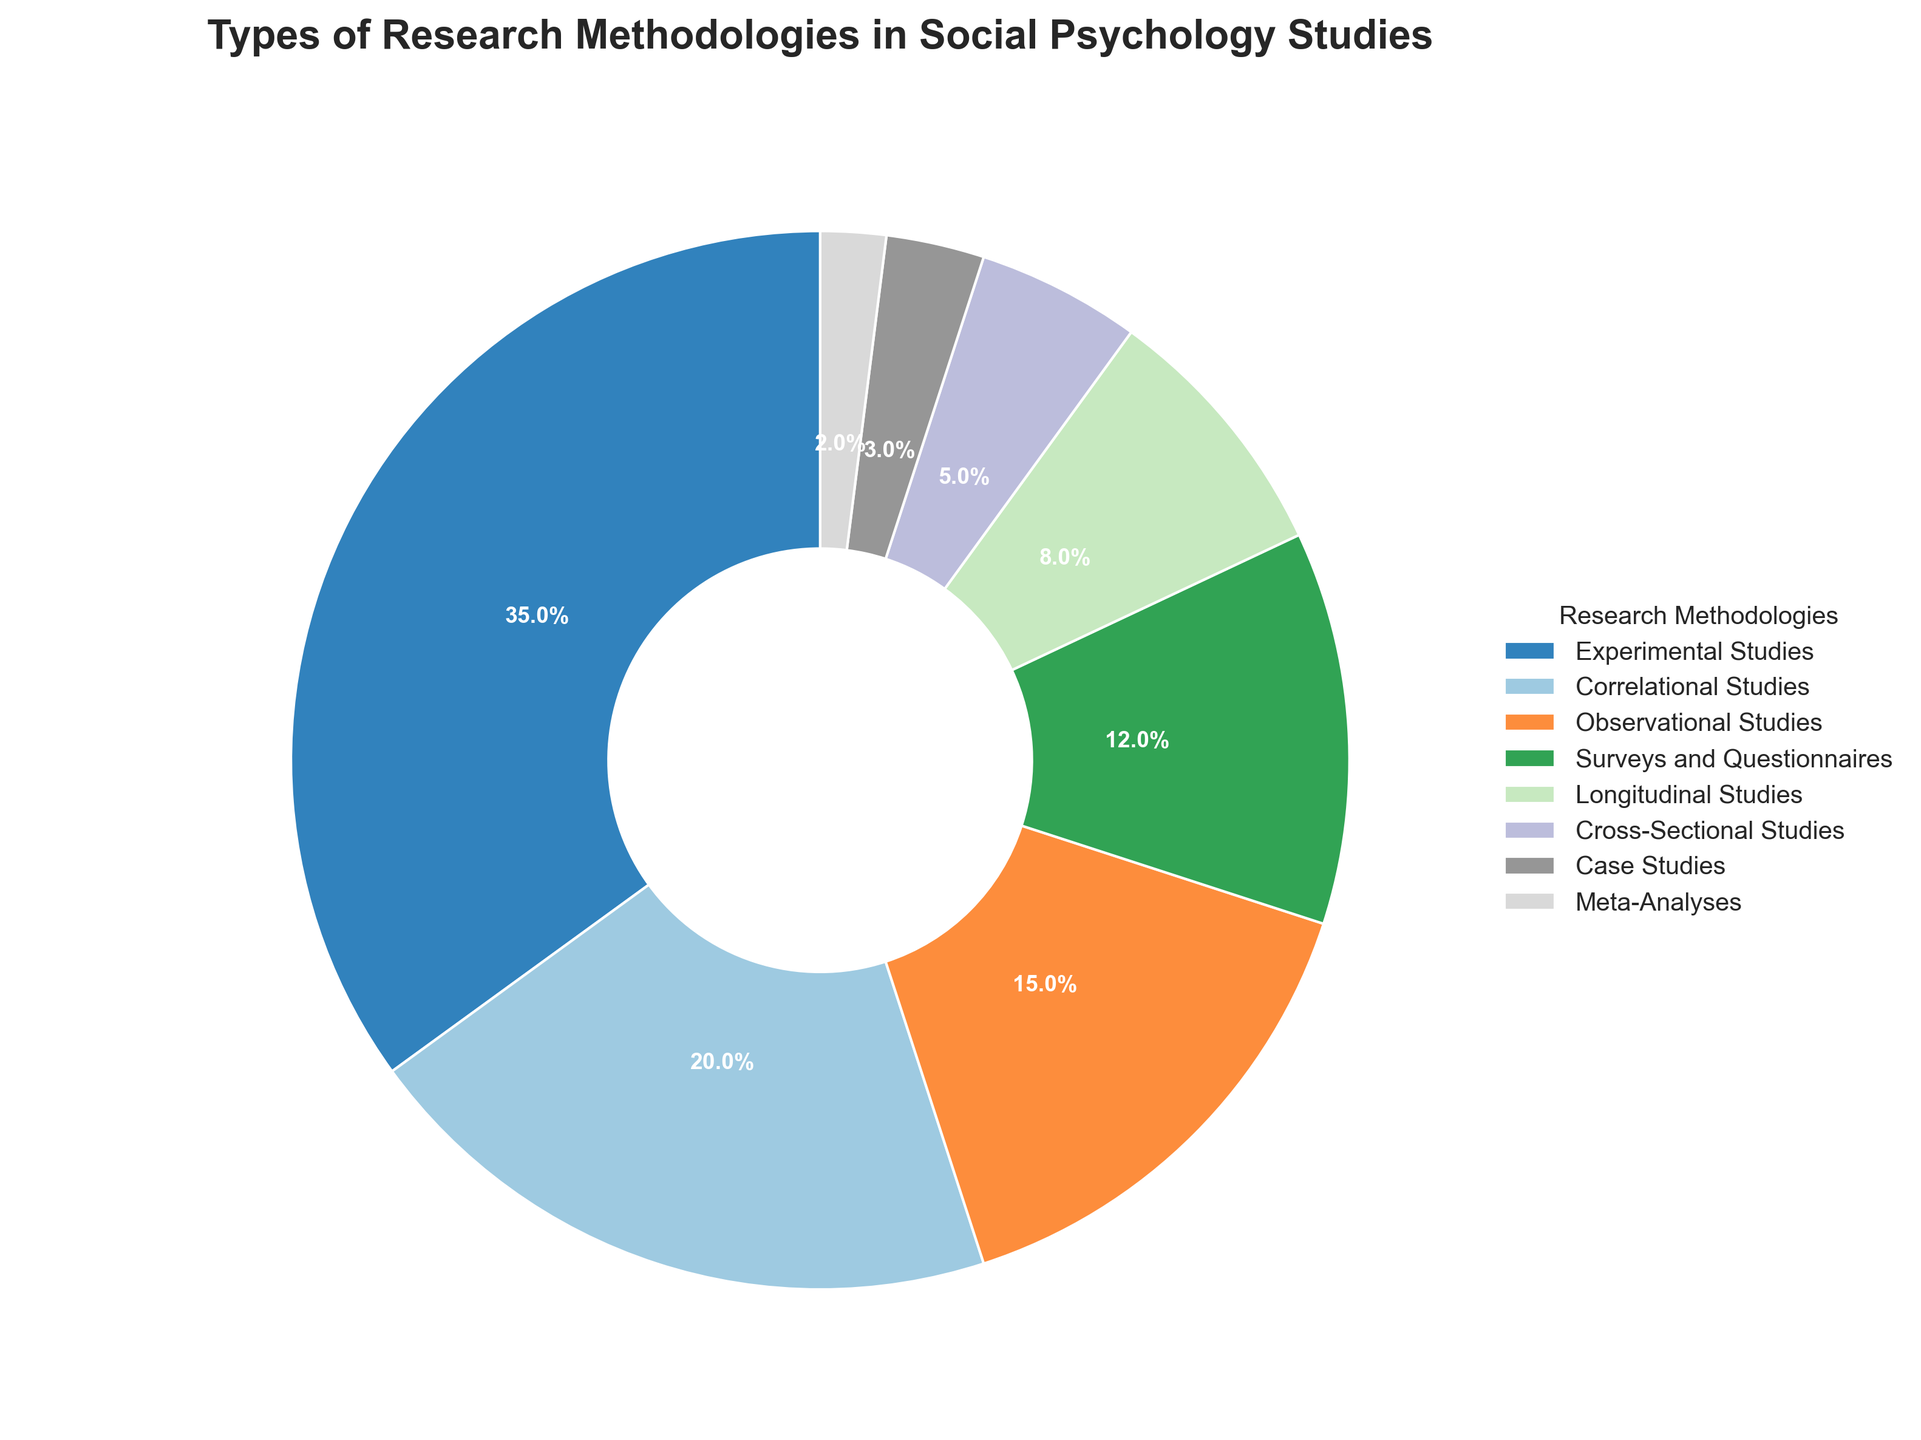Which research methodology is used the most in social psychology studies? The figure shows that "Experimental Studies" has the largest slice of the pie chart with 35%, indicating it is the most used research methodology.
Answer: Experimental Studies What is the combined percentage of Observational Studies and Surveys and Questionnaires? Observational Studies account for 15%, and Surveys and Questionnaires account for 12%. Adding these, 15 + 12 = 27%.
Answer: 27% Are Meta-Analyses used more or less frequently than Case Studies in social psychology research? Meta-Analyses appear as a 2% slice and Case Studies as a 3% slice of the pie chart, showing that Meta-Analyses are used less frequently than Case Studies.
Answer: Less What is the total percentage of methodologies that fall under 10% usage? The methodologies under 10% usage are Longitudinal Studies (8%), Cross-Sectional Studies (5%), Case Studies (3%), and Meta-Analyses (2%). Summing these values, 8 + 5 + 3 + 2 = 18%.
Answer: 18% Which methodology is placed between Correlational Studies and Surveys and Questionnaires in terms of percentage? Observational Studies, with a percentage of 15%, falls between Correlational Studies (20%) and Surveys and Questionnaires (12%) in the pie chart.
Answer: Observational Studies 